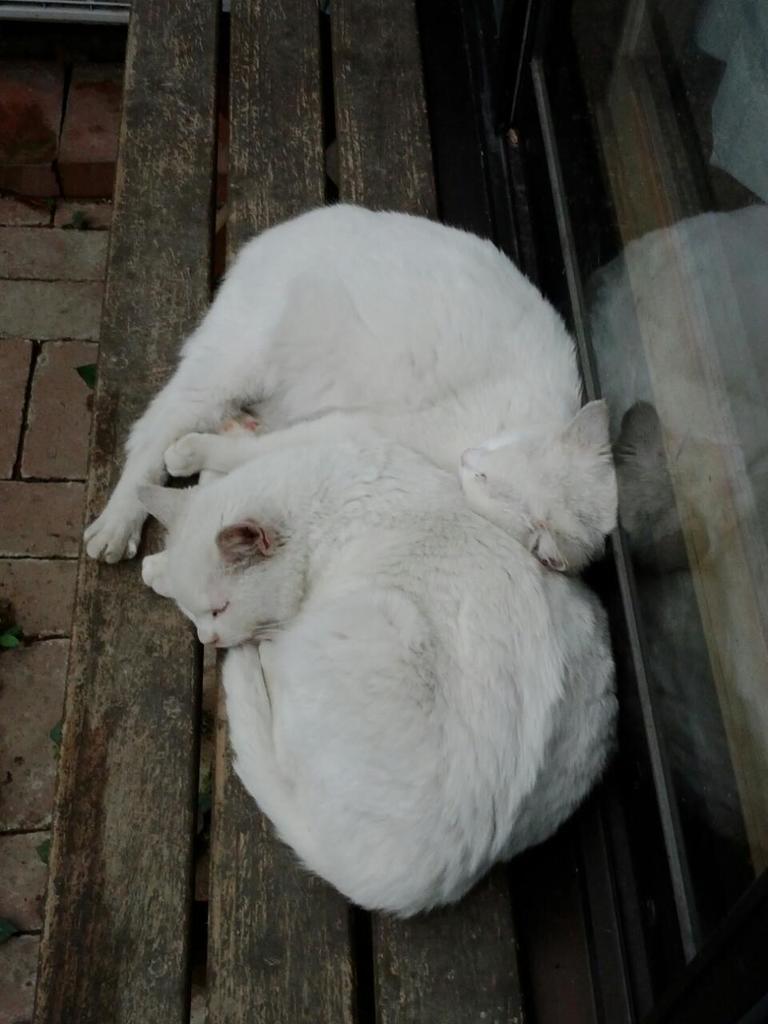How would you summarize this image in a sentence or two? In this image, I can see two white cats sleeping on a wooden bench. On the right side of the image, that looks like a glass door. On the left side of the image, I think this is a floor. 